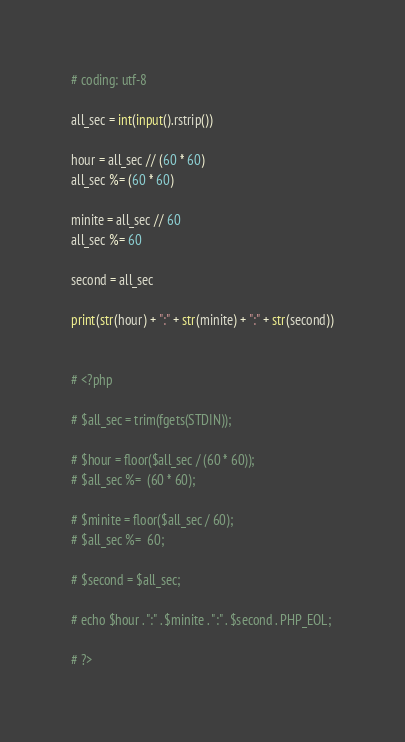Convert code to text. <code><loc_0><loc_0><loc_500><loc_500><_Python_># coding: utf-8

all_sec = int(input().rstrip())

hour = all_sec // (60 * 60)
all_sec %= (60 * 60)

minite = all_sec // 60
all_sec %= 60

second = all_sec

print(str(hour) + ":" + str(minite) + ":" + str(second))


# <?php

# $all_sec = trim(fgets(STDIN));

# $hour = floor($all_sec / (60 * 60));
# $all_sec %=  (60 * 60);

# $minite = floor($all_sec / 60);
# $all_sec %=  60;

# $second = $all_sec;

# echo $hour . ":" . $minite . ":" . $second . PHP_EOL;

# ?>
</code> 